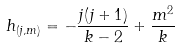<formula> <loc_0><loc_0><loc_500><loc_500>h _ { ( j , m ) } = - \frac { j ( j + 1 ) } { k - 2 } + \frac { m ^ { 2 } } { k }</formula> 